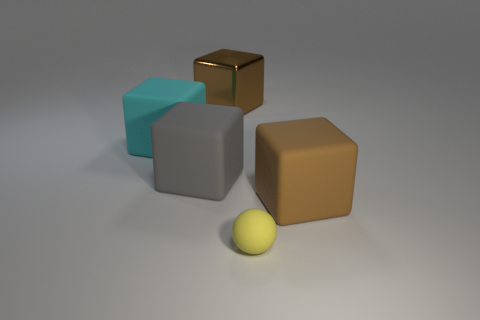Add 5 tiny rubber things. How many objects exist? 10 Subtract all brown metal cubes. How many cubes are left? 3 Subtract all gray blocks. How many blocks are left? 3 Subtract all blocks. How many objects are left? 1 Subtract 3 blocks. How many blocks are left? 1 Subtract all gray cubes. Subtract all blue cylinders. How many cubes are left? 3 Subtract all green spheres. How many brown cubes are left? 2 Subtract all large green things. Subtract all big metallic cubes. How many objects are left? 4 Add 5 brown objects. How many brown objects are left? 7 Add 4 small yellow matte things. How many small yellow matte things exist? 5 